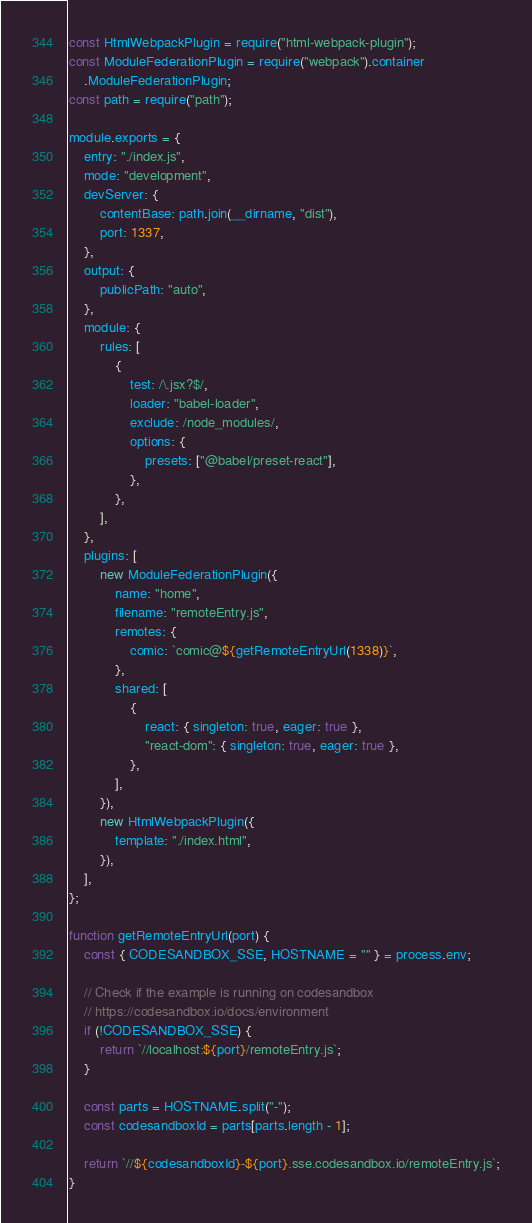<code> <loc_0><loc_0><loc_500><loc_500><_JavaScript_>const HtmlWebpackPlugin = require("html-webpack-plugin");
const ModuleFederationPlugin = require("webpack").container
	.ModuleFederationPlugin;
const path = require("path");

module.exports = {
	entry: "./index.js",
	mode: "development",
	devServer: {
		contentBase: path.join(__dirname, "dist"),
		port: 1337,
	},
	output: {
		publicPath: "auto",
	},
	module: {
		rules: [
			{
				test: /\.jsx?$/,
				loader: "babel-loader",
				exclude: /node_modules/,
				options: {
					presets: ["@babel/preset-react"],
				},
			},
		],
	},
	plugins: [
		new ModuleFederationPlugin({
			name: "home",
			filename: "remoteEntry.js",
			remotes: {
				comic: `comic@${getRemoteEntryUrl(1338)}`,
			},
			shared: [
				{
					react: { singleton: true, eager: true },
					"react-dom": { singleton: true, eager: true },
				},
			],
		}),
		new HtmlWebpackPlugin({
			template: "./index.html",
		}),
	],
};

function getRemoteEntryUrl(port) {
	const { CODESANDBOX_SSE, HOSTNAME = "" } = process.env;

	// Check if the example is running on codesandbox
	// https://codesandbox.io/docs/environment
	if (!CODESANDBOX_SSE) {
		return `//localhost:${port}/remoteEntry.js`;
	}

	const parts = HOSTNAME.split("-");
	const codesandboxId = parts[parts.length - 1];

	return `//${codesandboxId}-${port}.sse.codesandbox.io/remoteEntry.js`;
}
</code> 